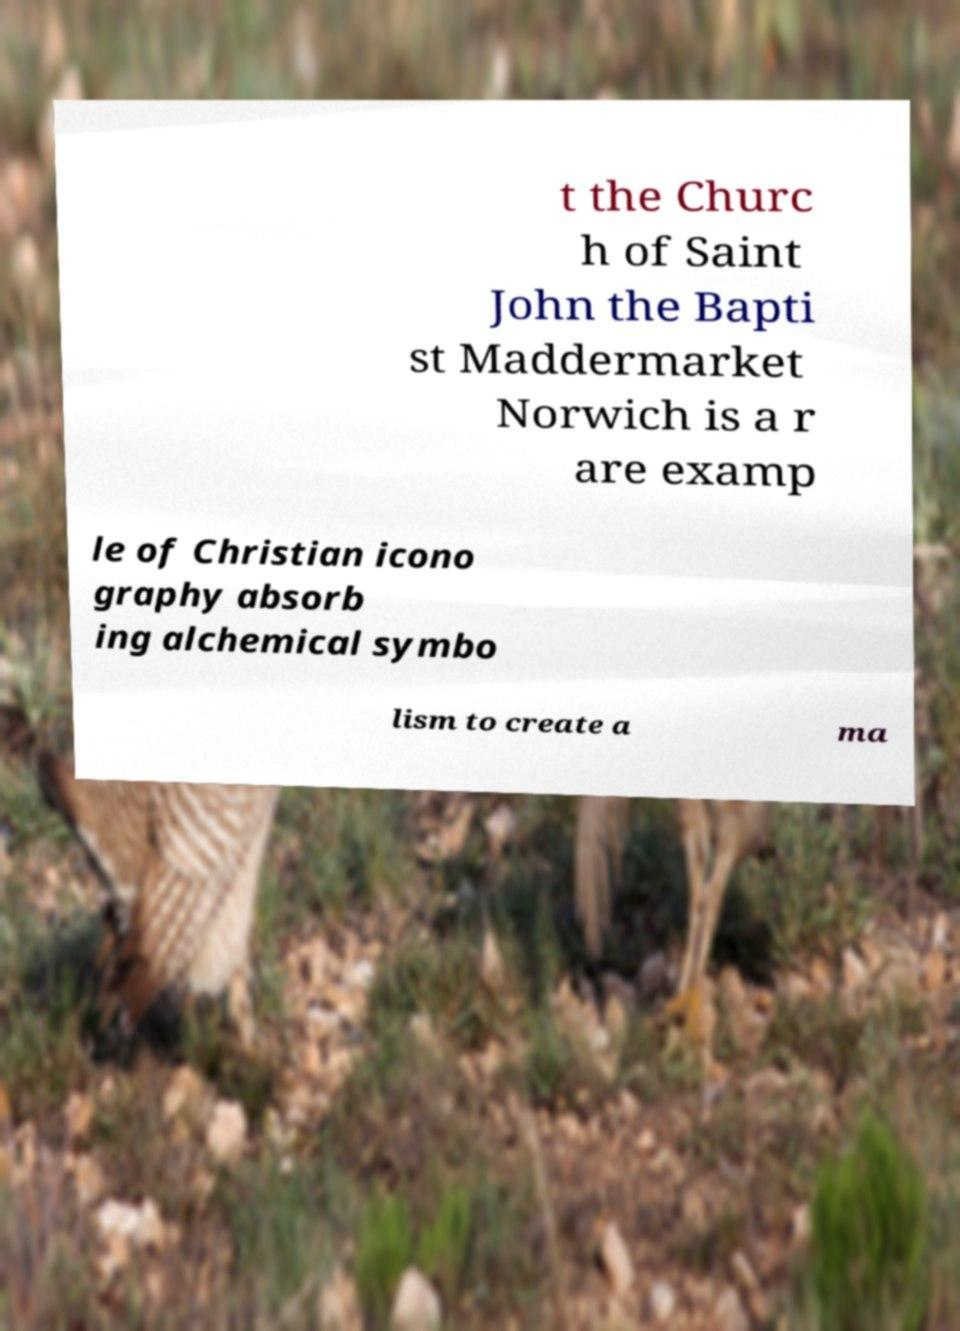For documentation purposes, I need the text within this image transcribed. Could you provide that? t the Churc h of Saint John the Bapti st Maddermarket Norwich is a r are examp le of Christian icono graphy absorb ing alchemical symbo lism to create a ma 